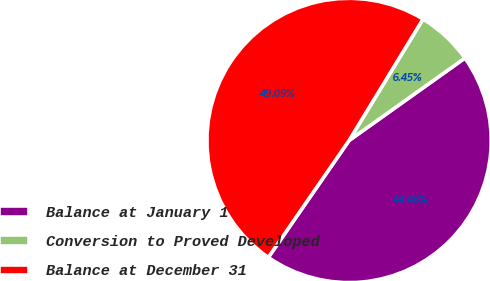<chart> <loc_0><loc_0><loc_500><loc_500><pie_chart><fcel>Balance at January 1<fcel>Conversion to Proved Developed<fcel>Balance at December 31<nl><fcel>44.46%<fcel>6.45%<fcel>49.09%<nl></chart> 